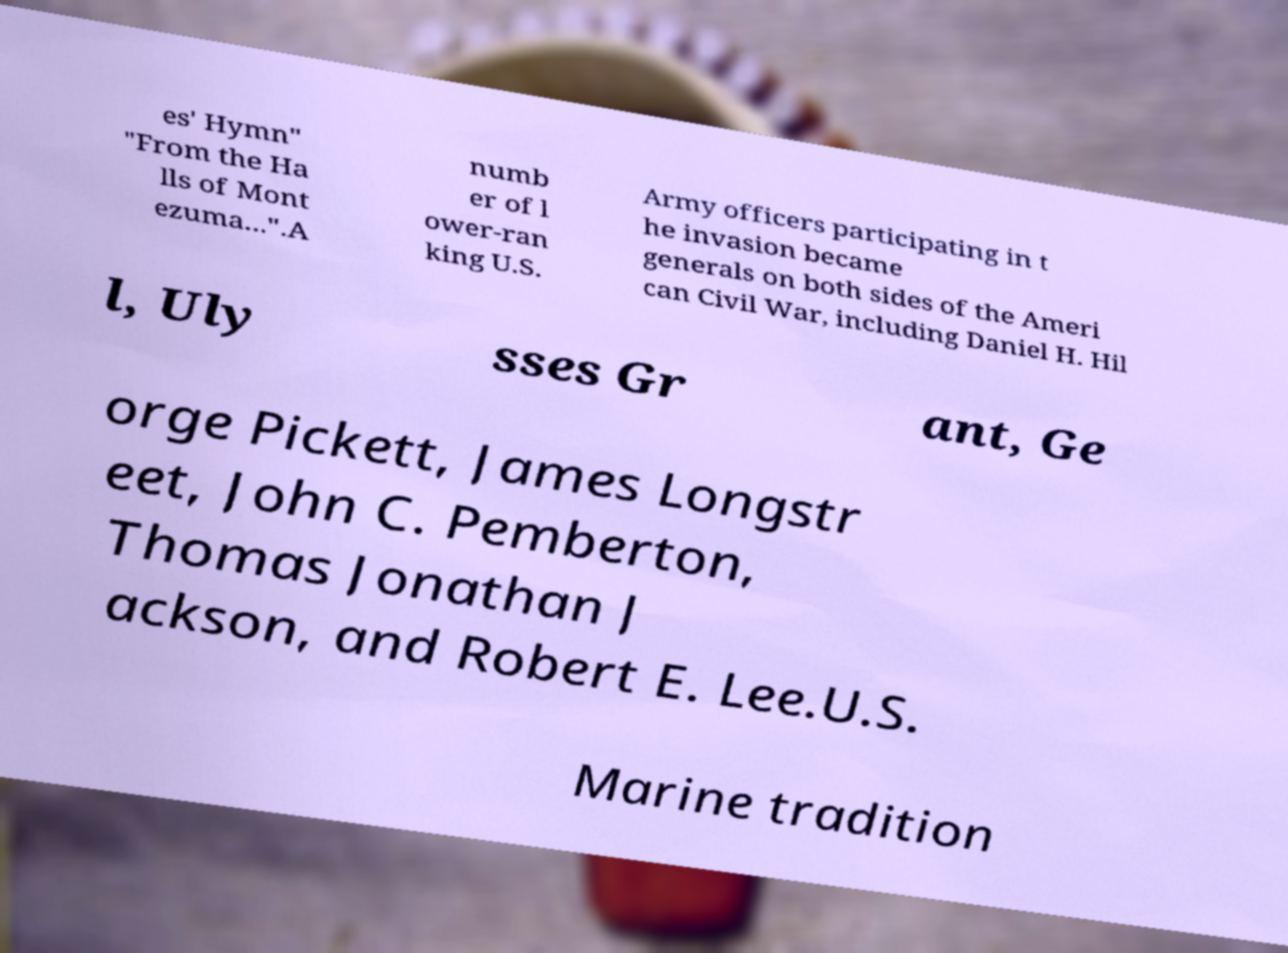I need the written content from this picture converted into text. Can you do that? es' Hymn" "From the Ha lls of Mont ezuma...".A numb er of l ower-ran king U.S. Army officers participating in t he invasion became generals on both sides of the Ameri can Civil War, including Daniel H. Hil l, Uly sses Gr ant, Ge orge Pickett, James Longstr eet, John C. Pemberton, Thomas Jonathan J ackson, and Robert E. Lee.U.S. Marine tradition 